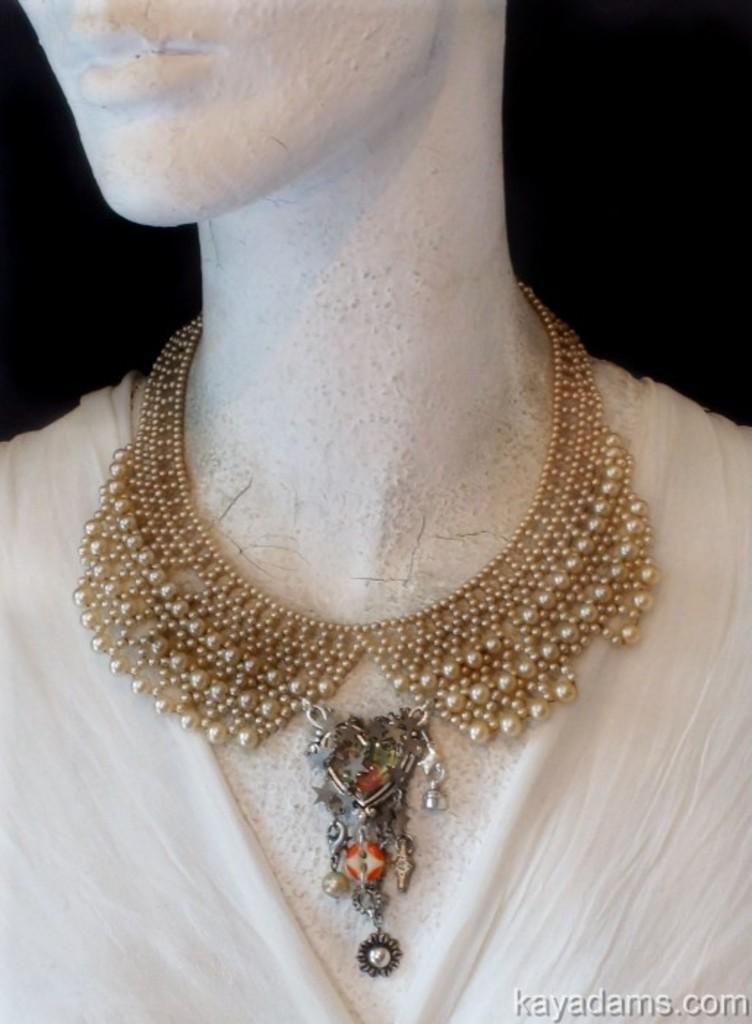How would you summarize this image in a sentence or two? In this image I can see a mannequin which is white in color and a necklace which is gold in color to the mannequin. I can see the black colored background. 